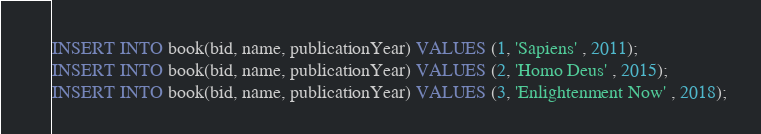<code> <loc_0><loc_0><loc_500><loc_500><_SQL_>INSERT INTO book(bid, name, publicationYear) VALUES (1, 'Sapiens' , 2011);
INSERT INTO book(bid, name, publicationYear) VALUES (2, 'Homo Deus' , 2015);
INSERT INTO book(bid, name, publicationYear) VALUES (3, 'Enlightenment Now' , 2018);</code> 